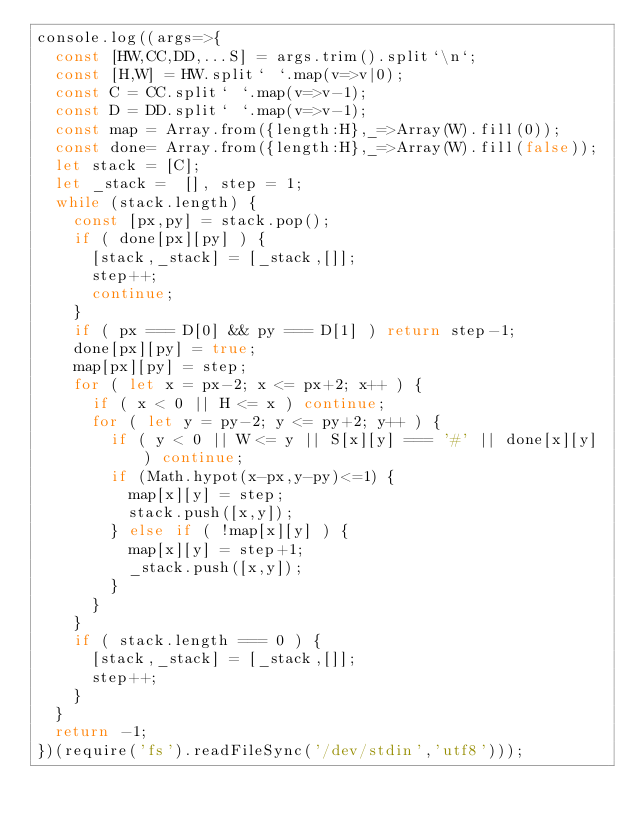Convert code to text. <code><loc_0><loc_0><loc_500><loc_500><_JavaScript_>console.log((args=>{
  const [HW,CC,DD,...S] = args.trim().split`\n`;
  const [H,W] = HW.split` `.map(v=>v|0);
  const C = CC.split` `.map(v=>v-1);
  const D = DD.split` `.map(v=>v-1);
  const map = Array.from({length:H},_=>Array(W).fill(0));
  const done= Array.from({length:H},_=>Array(W).fill(false));
  let stack = [C];
  let _stack =  [], step = 1;
  while (stack.length) {
    const [px,py] = stack.pop();
    if ( done[px][py] ) {
      [stack,_stack] = [_stack,[]];
      step++;
      continue;
    }
    if ( px === D[0] && py === D[1] ) return step-1;
    done[px][py] = true;
    map[px][py] = step;
    for ( let x = px-2; x <= px+2; x++ ) {
      if ( x < 0 || H <= x ) continue;
      for ( let y = py-2; y <= py+2; y++ ) {
        if ( y < 0 || W <= y || S[x][y] === '#' || done[x][y] ) continue;
        if (Math.hypot(x-px,y-py)<=1) {
          map[x][y] = step;
          stack.push([x,y]);
        } else if ( !map[x][y] ) {
          map[x][y] = step+1;
          _stack.push([x,y]);
        }
      }
    }
    if ( stack.length === 0 ) {
      [stack,_stack] = [_stack,[]];
      step++;
    }
  }
  return -1;
})(require('fs').readFileSync('/dev/stdin','utf8')));</code> 